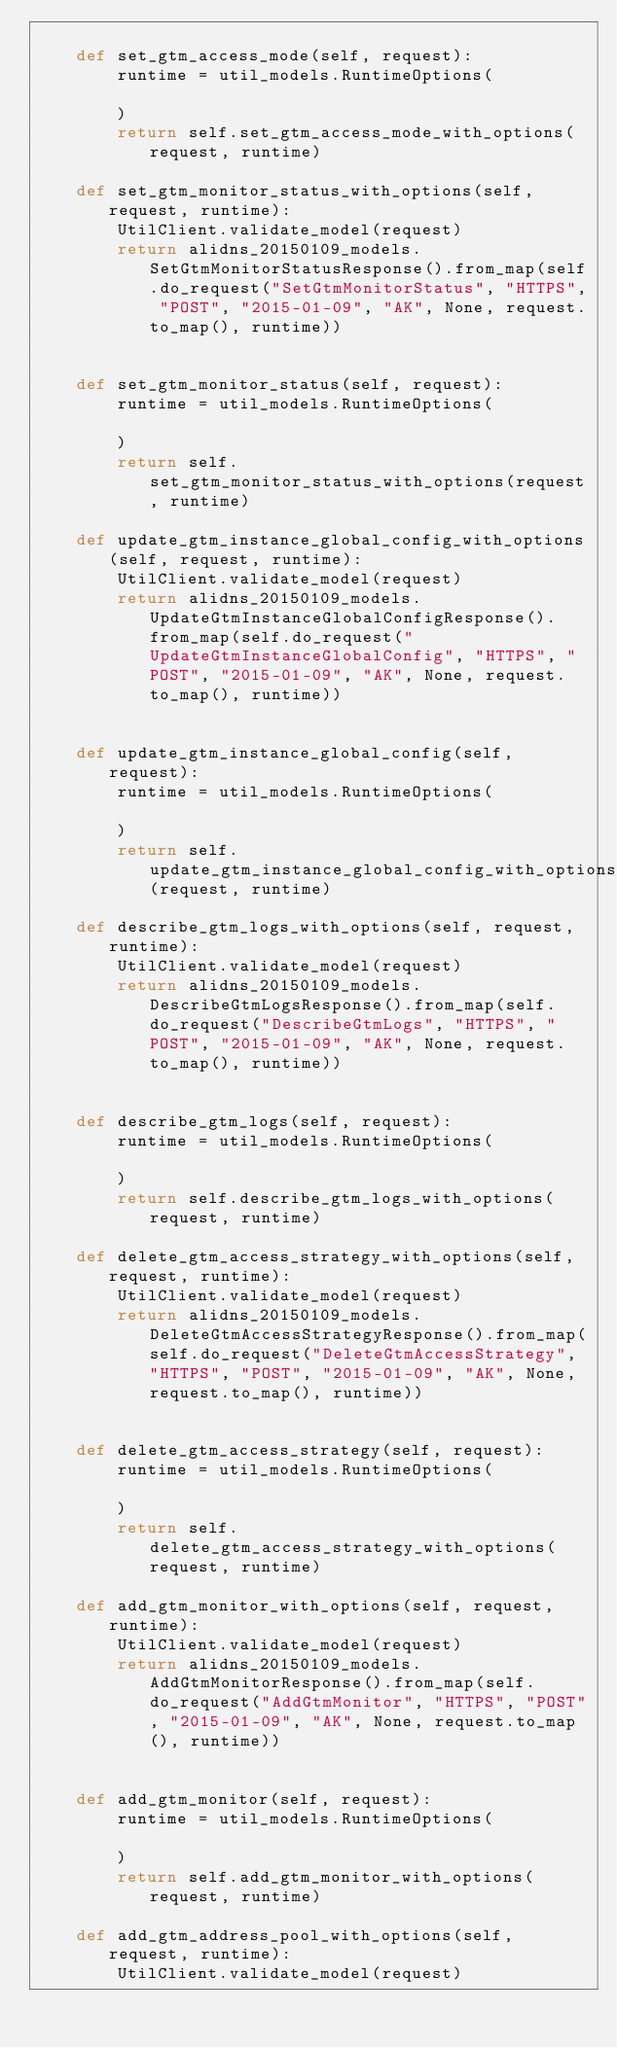<code> <loc_0><loc_0><loc_500><loc_500><_Python_>
    def set_gtm_access_mode(self, request):
        runtime = util_models.RuntimeOptions(

        )
        return self.set_gtm_access_mode_with_options(request, runtime)

    def set_gtm_monitor_status_with_options(self, request, runtime):
        UtilClient.validate_model(request)
        return alidns_20150109_models.SetGtmMonitorStatusResponse().from_map(self.do_request("SetGtmMonitorStatus", "HTTPS", "POST", "2015-01-09", "AK", None, request.to_map(), runtime))


    def set_gtm_monitor_status(self, request):
        runtime = util_models.RuntimeOptions(

        )
        return self.set_gtm_monitor_status_with_options(request, runtime)

    def update_gtm_instance_global_config_with_options(self, request, runtime):
        UtilClient.validate_model(request)
        return alidns_20150109_models.UpdateGtmInstanceGlobalConfigResponse().from_map(self.do_request("UpdateGtmInstanceGlobalConfig", "HTTPS", "POST", "2015-01-09", "AK", None, request.to_map(), runtime))


    def update_gtm_instance_global_config(self, request):
        runtime = util_models.RuntimeOptions(

        )
        return self.update_gtm_instance_global_config_with_options(request, runtime)

    def describe_gtm_logs_with_options(self, request, runtime):
        UtilClient.validate_model(request)
        return alidns_20150109_models.DescribeGtmLogsResponse().from_map(self.do_request("DescribeGtmLogs", "HTTPS", "POST", "2015-01-09", "AK", None, request.to_map(), runtime))


    def describe_gtm_logs(self, request):
        runtime = util_models.RuntimeOptions(

        )
        return self.describe_gtm_logs_with_options(request, runtime)

    def delete_gtm_access_strategy_with_options(self, request, runtime):
        UtilClient.validate_model(request)
        return alidns_20150109_models.DeleteGtmAccessStrategyResponse().from_map(self.do_request("DeleteGtmAccessStrategy", "HTTPS", "POST", "2015-01-09", "AK", None, request.to_map(), runtime))


    def delete_gtm_access_strategy(self, request):
        runtime = util_models.RuntimeOptions(

        )
        return self.delete_gtm_access_strategy_with_options(request, runtime)

    def add_gtm_monitor_with_options(self, request, runtime):
        UtilClient.validate_model(request)
        return alidns_20150109_models.AddGtmMonitorResponse().from_map(self.do_request("AddGtmMonitor", "HTTPS", "POST", "2015-01-09", "AK", None, request.to_map(), runtime))


    def add_gtm_monitor(self, request):
        runtime = util_models.RuntimeOptions(

        )
        return self.add_gtm_monitor_with_options(request, runtime)

    def add_gtm_address_pool_with_options(self, request, runtime):
        UtilClient.validate_model(request)</code> 